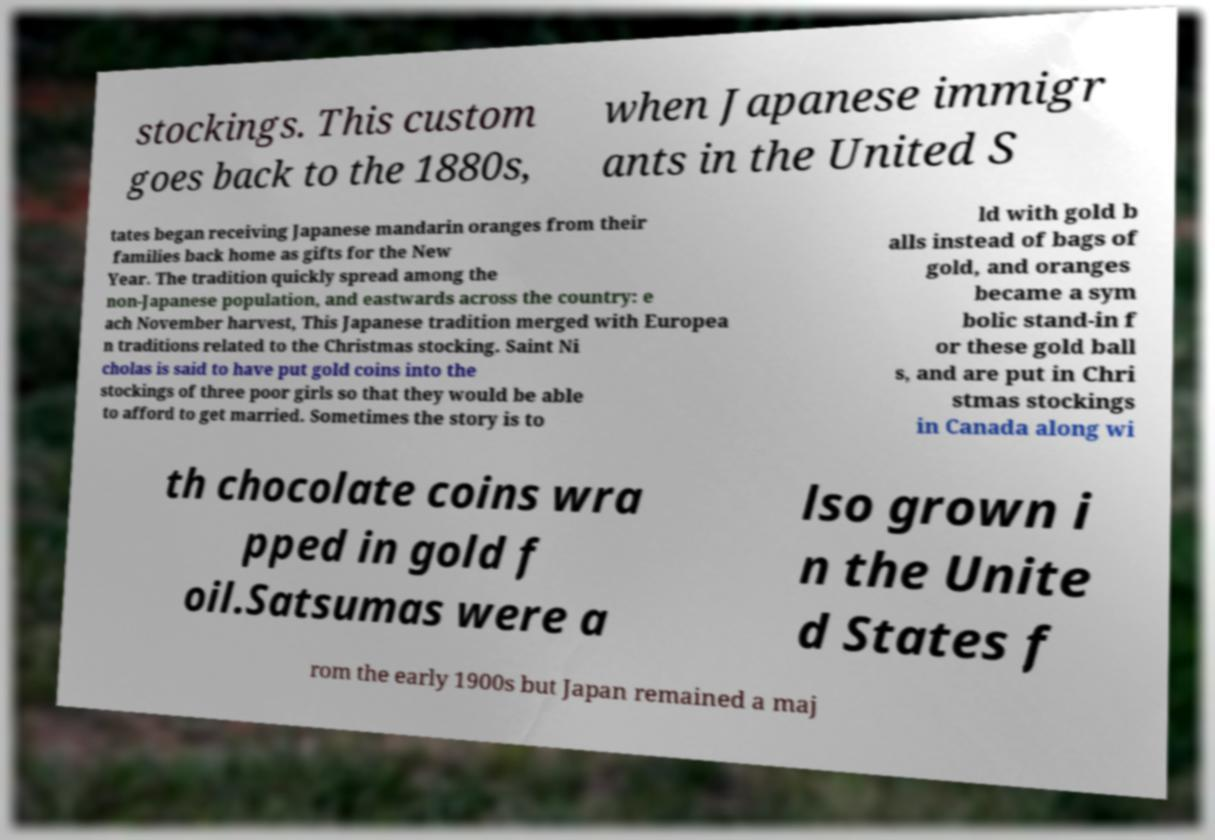Can you accurately transcribe the text from the provided image for me? stockings. This custom goes back to the 1880s, when Japanese immigr ants in the United S tates began receiving Japanese mandarin oranges from their families back home as gifts for the New Year. The tradition quickly spread among the non-Japanese population, and eastwards across the country: e ach November harvest, This Japanese tradition merged with Europea n traditions related to the Christmas stocking. Saint Ni cholas is said to have put gold coins into the stockings of three poor girls so that they would be able to afford to get married. Sometimes the story is to ld with gold b alls instead of bags of gold, and oranges became a sym bolic stand-in f or these gold ball s, and are put in Chri stmas stockings in Canada along wi th chocolate coins wra pped in gold f oil.Satsumas were a lso grown i n the Unite d States f rom the early 1900s but Japan remained a maj 